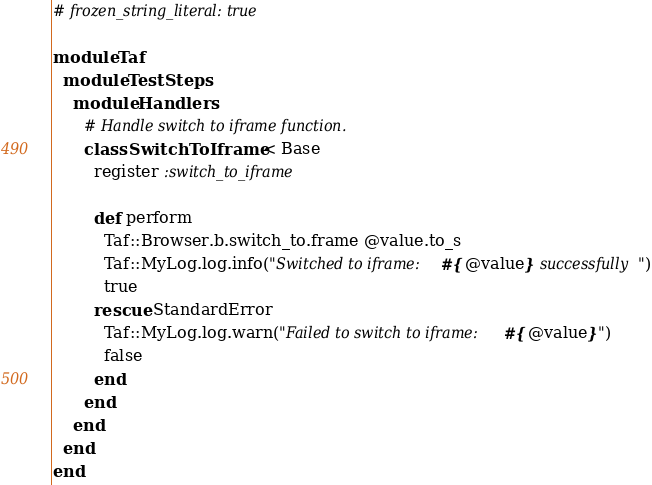<code> <loc_0><loc_0><loc_500><loc_500><_Ruby_># frozen_string_literal: true

module Taf
  module TestSteps
    module Handlers
      # Handle switch to iframe function.
      class SwitchToIframe < Base
        register :switch_to_iframe

        def perform
          Taf::Browser.b.switch_to.frame @value.to_s
          Taf::MyLog.log.info("Switched to iframe: #{@value} successfully")
          true
        rescue StandardError
          Taf::MyLog.log.warn("Failed to switch to iframe: #{@value}")
          false
        end
      end
    end
  end
end
</code> 